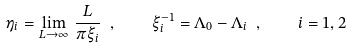<formula> <loc_0><loc_0><loc_500><loc_500>\eta _ { i } = \lim _ { L \to \infty } \, \frac { L } { \pi \xi _ { i } } \ , \quad \xi _ { i } ^ { - 1 } = \Lambda _ { 0 } - \Lambda _ { i } \ , \quad i = 1 , 2</formula> 